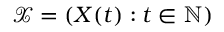<formula> <loc_0><loc_0><loc_500><loc_500>\mathcal { X } = ( X ( t ) \colon t \in \mathbb { N } )</formula> 